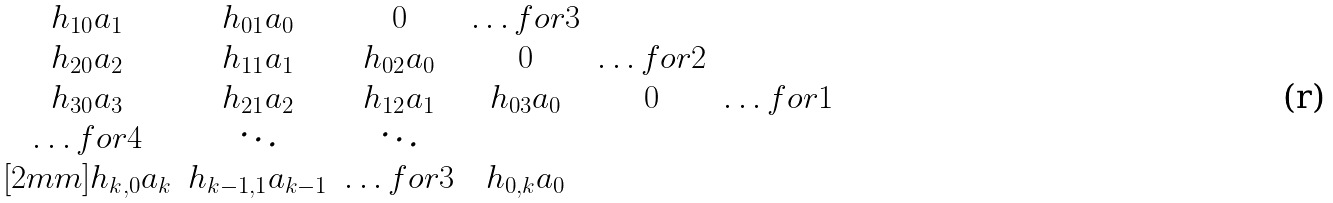<formula> <loc_0><loc_0><loc_500><loc_500>\begin{matrix} h _ { 1 0 } a _ { 1 } & h _ { 0 1 } a _ { 0 } & 0 & \hdots f o r { 3 } \\ h _ { 2 0 } a _ { 2 } & h _ { 1 1 } a _ { 1 } & h _ { 0 2 } a _ { 0 } & 0 & \hdots f o r { 2 } \\ h _ { 3 0 } a _ { 3 } & h _ { 2 1 } a _ { 2 } & h _ { 1 2 } a _ { 1 } & h _ { 0 3 } a _ { 0 } & 0 & \hdots f o r { 1 } \\ \hdots f o r { 4 } & \ddots & \ddots \\ [ 2 m m ] h _ { k , 0 } a _ { k } & h _ { k - 1 , 1 } a _ { k - 1 } & \hdots f o r { 3 } & h _ { 0 , k } a _ { 0 } \end{matrix}</formula> 